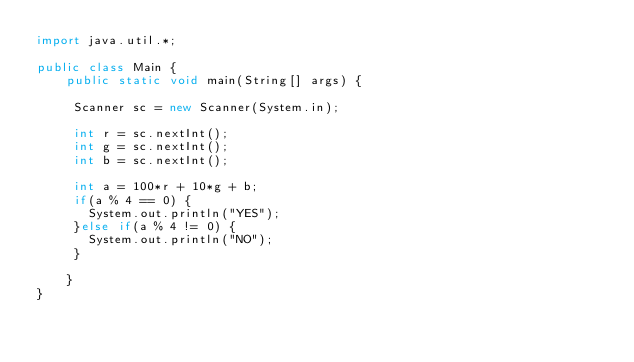<code> <loc_0><loc_0><loc_500><loc_500><_Java_>import java.util.*;

public class Main {
		public static void main(String[] args) {
		
	   Scanner sc = new Scanner(System.in);
	   
	   int r = sc.nextInt();
	   int g = sc.nextInt();
	   int b = sc.nextInt();
	   
	   int a = 100*r + 10*g + b;
	   if(a % 4 == 0) {
		   System.out.println("YES");
	   }else if(a % 4 != 0) {
		   System.out.println("NO");
	   }

		}
}</code> 